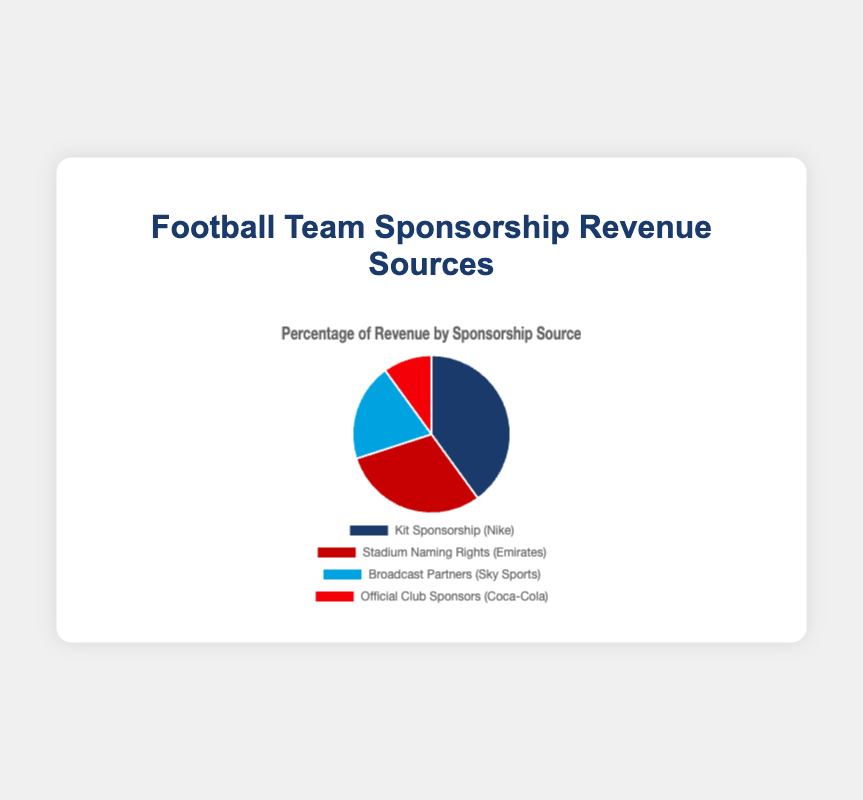What is the largest source of sponsorship revenue and what percentage does it contribute? Kit Sponsorship is the largest source of sponsorship revenue, contributing 40%. This information is found by looking at the segments in the pie chart and identifying the largest one.
Answer: Kit Sponsorship, 40% Which sponsorship source contributes the least to revenue? The segment labeled "Official Club Sponsors (Coca-Cola)" is the smallest in the pie chart, which means it contributes the least to revenue at 10%.
Answer: Official Club Sponsors, 10% How much more does the Kit Sponsorship contribute compared to the Broadcast Partners? To determine the difference, subtract the percentage of Broadcast Partners (20%) from the percentage of Kit Sponsorship (40%): 40% - 20% = 20%.
Answer: 20% What is the total percentage of revenue from Stadium Naming Rights and Broadcast Partners combined? Add the percentages for Stadium Naming Rights (30%) and Broadcast Partners (20%): 30% + 20% = 50%.
Answer: 50% Which sponsorship source is marked in red, and what is its revenue percentage? The "Official Club Sponsors (Coca-Cola)" segment is marked in red as per the chart's color scheme. It represents 10% of the revenue.
Answer: Official Club Sponsors, 10% How does the percentage of revenue from Broadcast Partners compare to that from Official Club Sponsors? Broadcast Partners (20%) contribute more than Official Club Sponsors (10%). This is evident by visually comparing the segments or directly looking at the percentages.
Answer: Broadcast Partners, more If Kit Sponsorship and Stadium Naming Rights were combined into one category, what would their combined percentage of total revenue be? Combine the percentages of Kit Sponsorship (40%) and Stadium Naming Rights (30%): 40% + 30% = 70%.
Answer: 70% What percentage of the revenue is attributable to entities other than Nike and Emirates? Combine the percentages for Broadcast Partners (20%) and Official Club Sponsors (10%): 20% + 10% = 30%.
Answer: 30% Which two sources combined contribute exactly half of the total sponsorship revenue? The sum of Stadium Naming Rights (30%) and Broadcast Partners (20%) equals 50%, which is half of the total sponsorship revenue.
Answer: Stadium Naming Rights and Broadcast Partners What would be the effect on the pie chart if the revenue from Official Club Sponsors doubled? The percentage for Official Club Sponsors would double from 10% to 20%, altering the distribution of the other segments to sum up to 100%. Exact visual changes can't be predicted without re-calculating the other percentages.
Answer: Increased from 10% to 20% and reallocation needed 